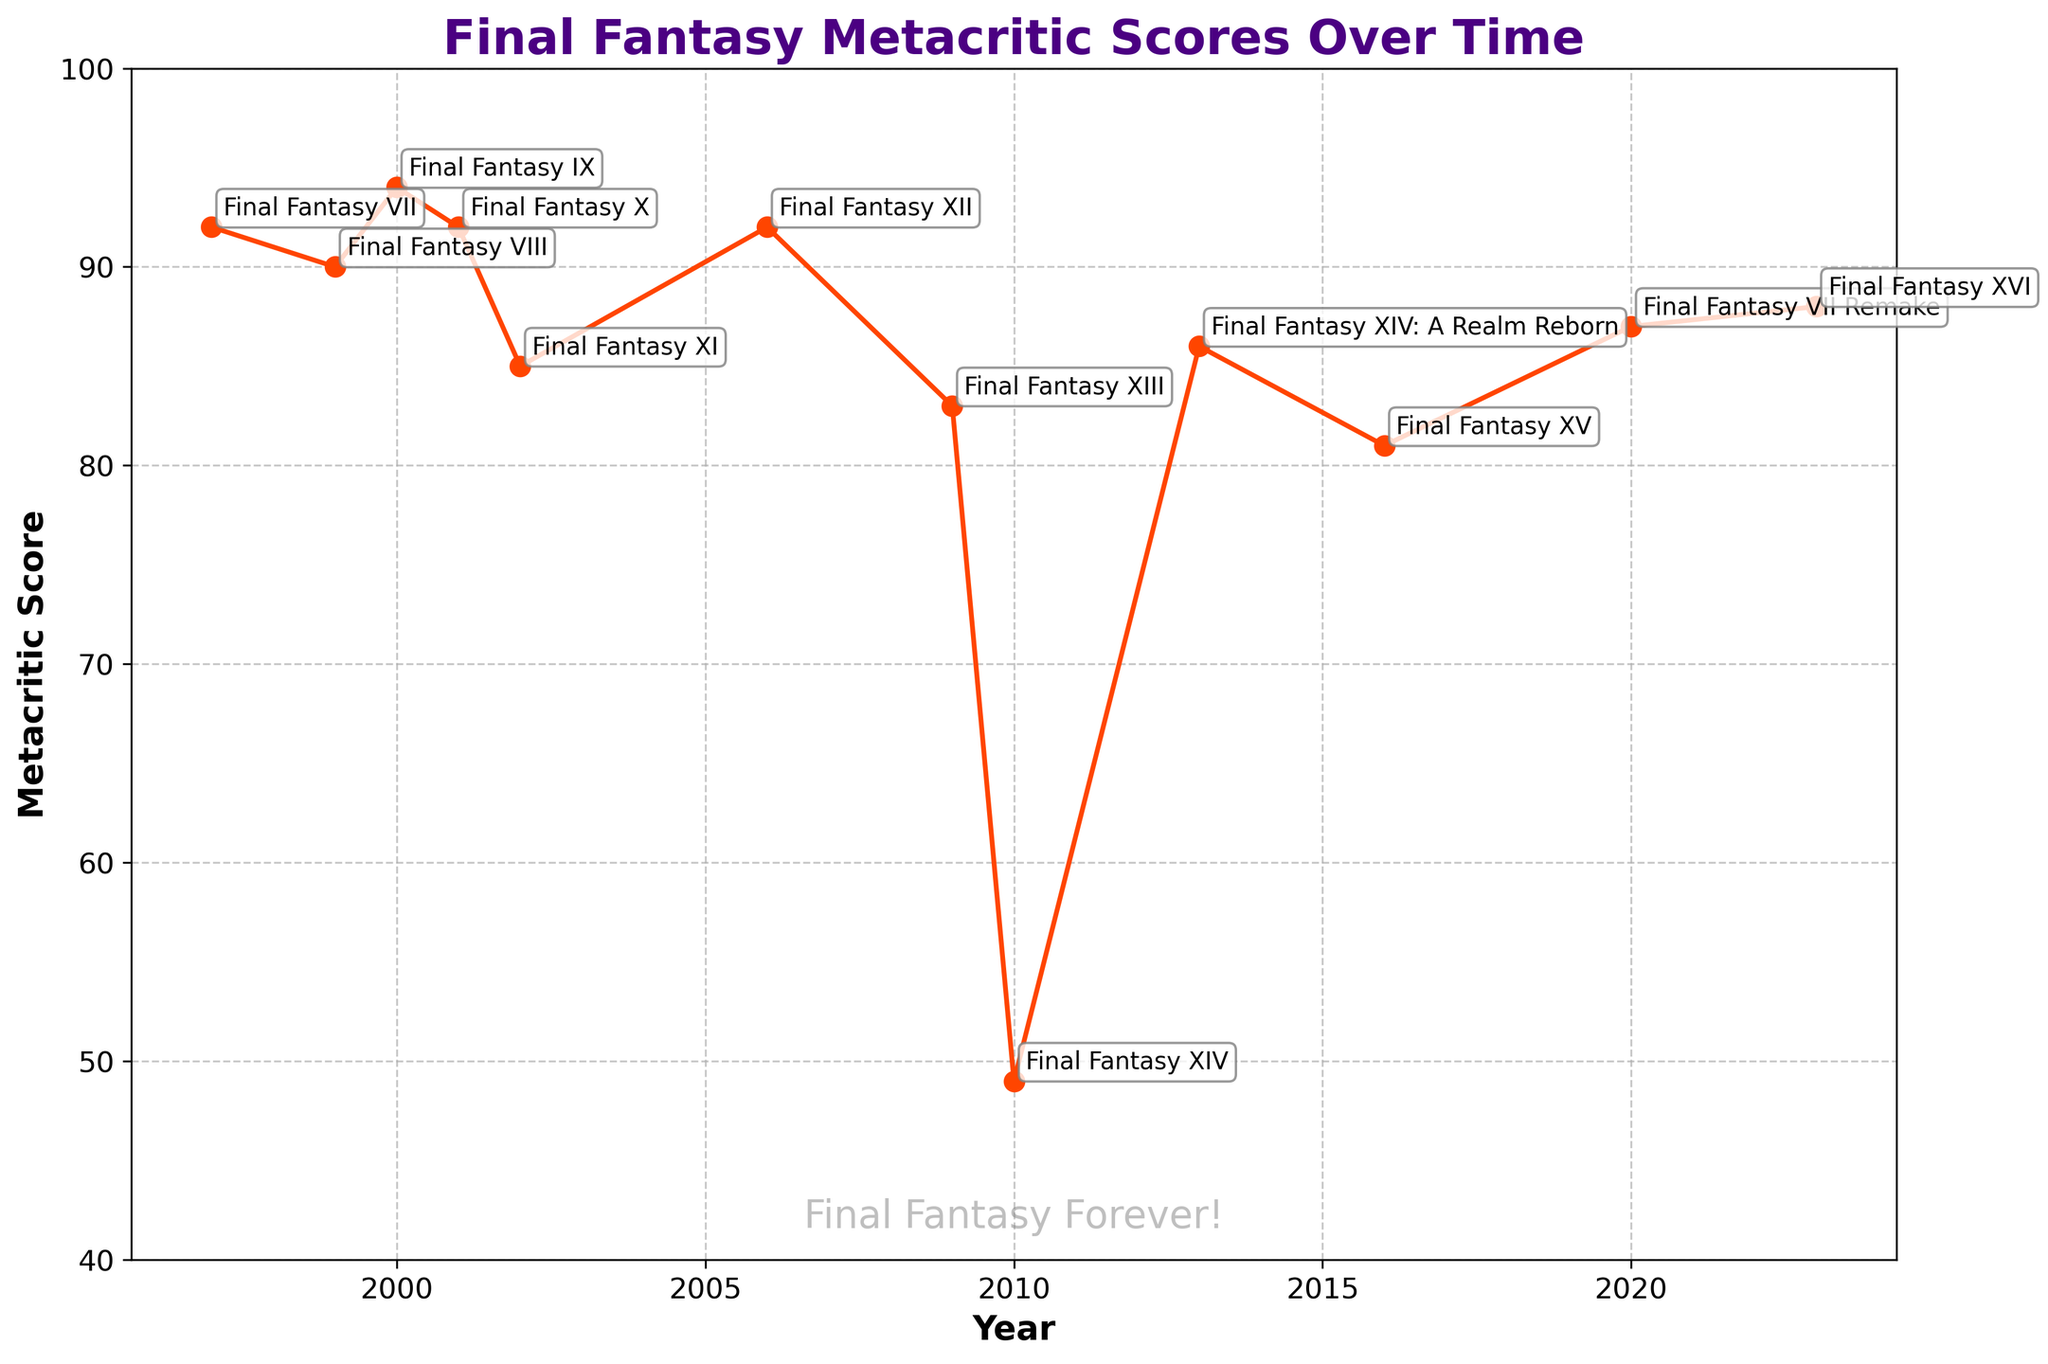What's the highest Metacritic score for a Final Fantasy game? Look at the line chart to identify the peak Metacritic score. The highest score is associated with Final Fantasy IX, which scored 94.
Answer: 94 Which Final Fantasy game received the lowest Metacritic score? Locate the lowest point on the line chart. The lowest Metacritic score is for Final Fantasy XIV, with a score of 49.
Answer: Final Fantasy XIV What is the difference in Metacritic scores between Final Fantasy XIII and Final Fantasy XV? Find the Metacritic scores for Final Fantasy XIII (83) and Final Fantasy XV (81), then subtract the score of XV from XIII. The difference is 83 - 81 = 2.
Answer: 2 Which game had a higher Metacritic score, Final Fantasy X or Final Fantasy VII Remake? Compare the scores on the line chart for Final Fantasy X (92) and Final Fantasy VII Remake (87). Final Fantasy X has a higher score.
Answer: Final Fantasy X What's the average Metacritic score of the Final Fantasy games released from 2010 onwards? Identify the games released from 2010 onwards: Final Fantasy XIV (49), Final Fantasy XIV: A Realm Reborn (86), Final Fantasy XV (81), Final Fantasy VII Remake (87), Final Fantasy XVI (88). Sum these scores (49 + 86 + 81 + 87 + 88 = 391) and divide by the number of games (5). The average is 391/5 = 78.2.
Answer: 78.2 How many Final Fantasy games have a Metacritic score above 90? Count the number of games that have scores above 90. Final Fantasy VII (92), Final Fantasy VIII (90), Final Fantasy IX (94), Final Fantasy X (92), and Final Fantasy XII (92) meet this criterion. There are 5 games in total.
Answer: 5 Which games saw an increase in Metacritic score compared to their immediate predecessor? Evaluate each pair of consecutive games to see if the latter has a higher score. The increases happened for Final Fantasy XIV: A Realm Reborn (49 to 86) and Final Fantasy XVI (81 to 88).
Answer: Final Fantasy XIV: A Realm Reborn, Final Fantasy XVI What's the difference between the highest and lowest Metacritic scores? Identify the highest score (94 for Final Fantasy IX) and the lowest score (49 for Final Fantasy XIV). Subtract the lowest from the highest: 94 - 49 = 45.
Answer: 45 Which game released in the 2000s has the highest Metacritic score? Look at the scores for games released between 2000 and 2009. The games are Final Fantasy IX (94), Final Fantasy X (92), Final Fantasy XI (85), Final Fantasy XII (92), Final Fantasy XIII (83). Final Fantasy IX has the highest score, 94, among them.
Answer: Final Fantasy IX 